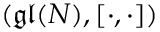Convert formula to latex. <formula><loc_0><loc_0><loc_500><loc_500>( \mathfrak { g l } ( N ) , [ \cdot , \cdot ] )</formula> 